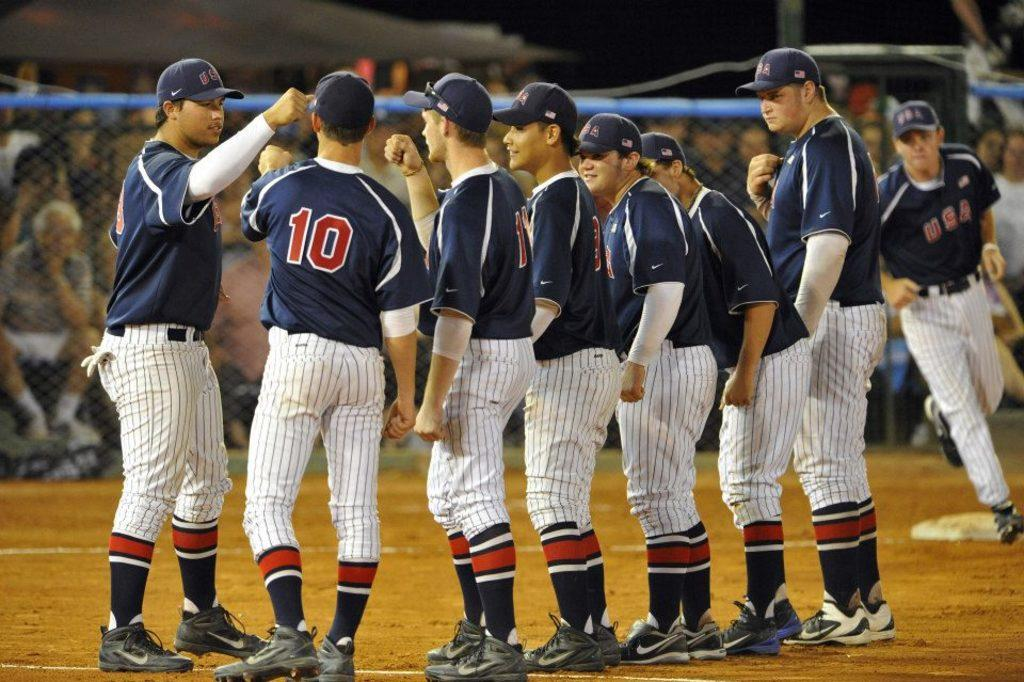Provide a one-sentence caption for the provided image. The baseball players on the field play for team USA. 